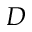Convert formula to latex. <formula><loc_0><loc_0><loc_500><loc_500>D</formula> 